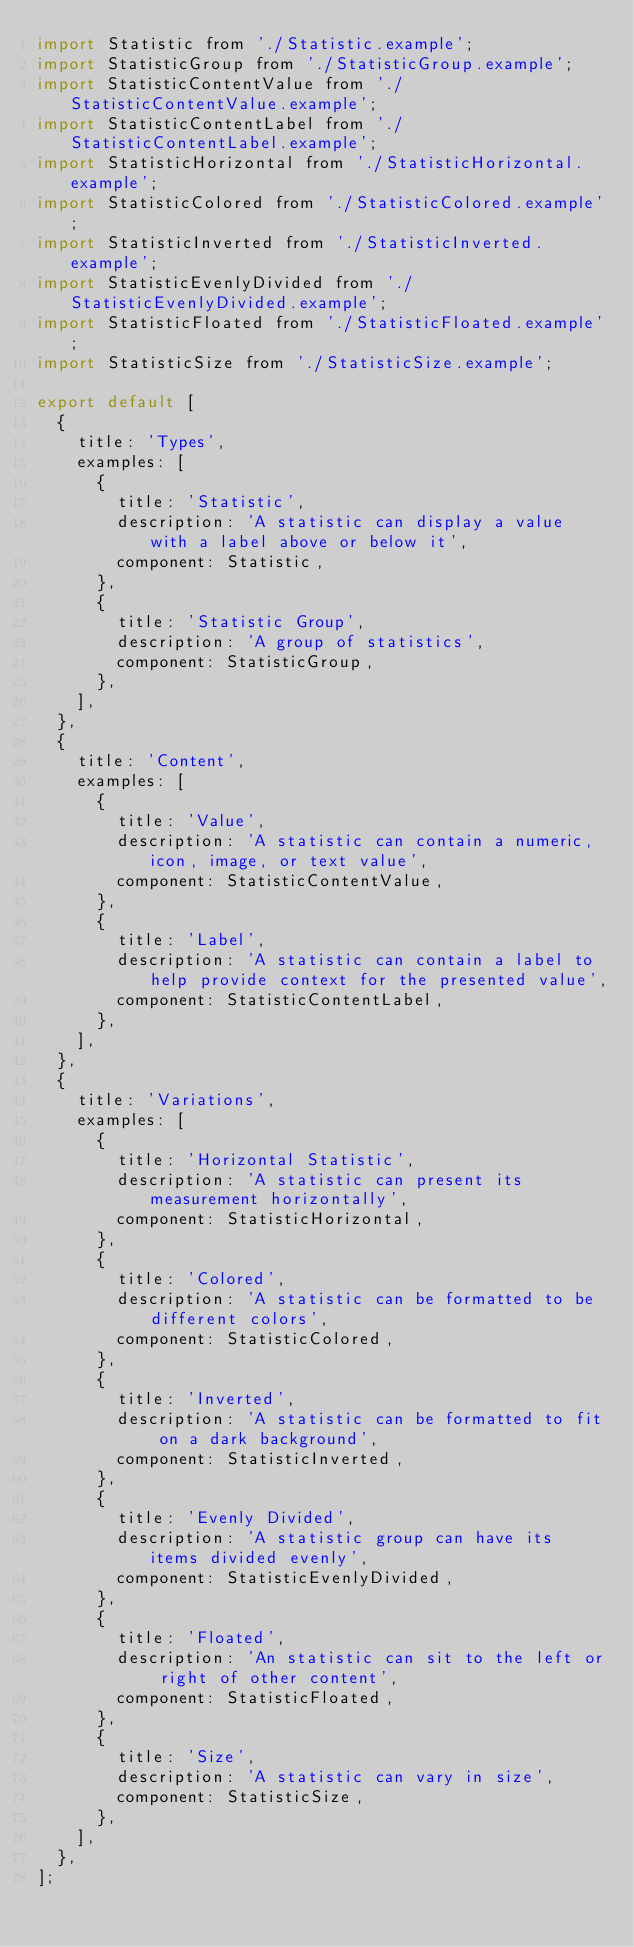Convert code to text. <code><loc_0><loc_0><loc_500><loc_500><_JavaScript_>import Statistic from './Statistic.example';
import StatisticGroup from './StatisticGroup.example';
import StatisticContentValue from './StatisticContentValue.example';
import StatisticContentLabel from './StatisticContentLabel.example';
import StatisticHorizontal from './StatisticHorizontal.example';
import StatisticColored from './StatisticColored.example';
import StatisticInverted from './StatisticInverted.example';
import StatisticEvenlyDivided from './StatisticEvenlyDivided.example';
import StatisticFloated from './StatisticFloated.example';
import StatisticSize from './StatisticSize.example';

export default [
  {
    title: 'Types',
    examples: [
      {
        title: 'Statistic',
        description: 'A statistic can display a value with a label above or below it',
        component: Statistic,
      },
      {
        title: 'Statistic Group',
        description: 'A group of statistics',
        component: StatisticGroup,
      },
    ],
  },
  {
    title: 'Content',
    examples: [
      {
        title: 'Value',
        description: 'A statistic can contain a numeric, icon, image, or text value',
        component: StatisticContentValue,
      },
      {
        title: 'Label',
        description: 'A statistic can contain a label to help provide context for the presented value',
        component: StatisticContentLabel,
      },
    ],
  },
  {
    title: 'Variations',
    examples: [
      {
        title: 'Horizontal Statistic',
        description: 'A statistic can present its measurement horizontally',
        component: StatisticHorizontal,
      },
      {
        title: 'Colored',
        description: 'A statistic can be formatted to be different colors',
        component: StatisticColored,
      },
      {
        title: 'Inverted',
        description: 'A statistic can be formatted to fit on a dark background',
        component: StatisticInverted,
      },
      {
        title: 'Evenly Divided',
        description: 'A statistic group can have its items divided evenly',
        component: StatisticEvenlyDivided,
      },
      {
        title: 'Floated',
        description: 'An statistic can sit to the left or right of other content',
        component: StatisticFloated,
      },
      {
        title: 'Size',
        description: 'A statistic can vary in size',
        component: StatisticSize,
      },
    ],
  },
];
</code> 